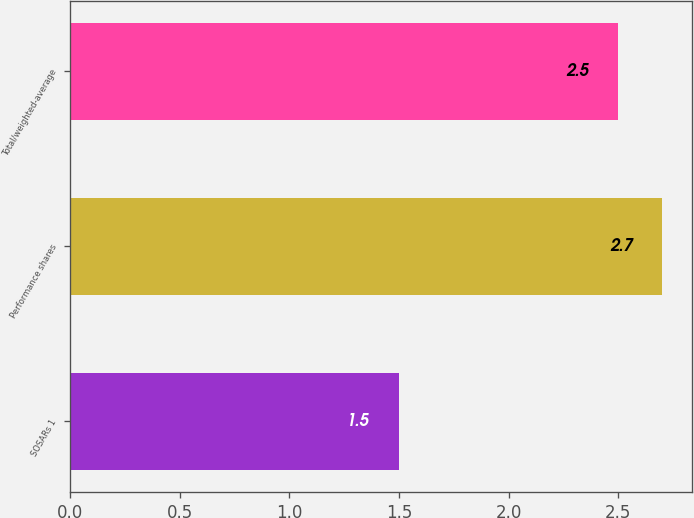<chart> <loc_0><loc_0><loc_500><loc_500><bar_chart><fcel>SOSARs 1<fcel>Performance shares<fcel>Total/weighted-average<nl><fcel>1.5<fcel>2.7<fcel>2.5<nl></chart> 